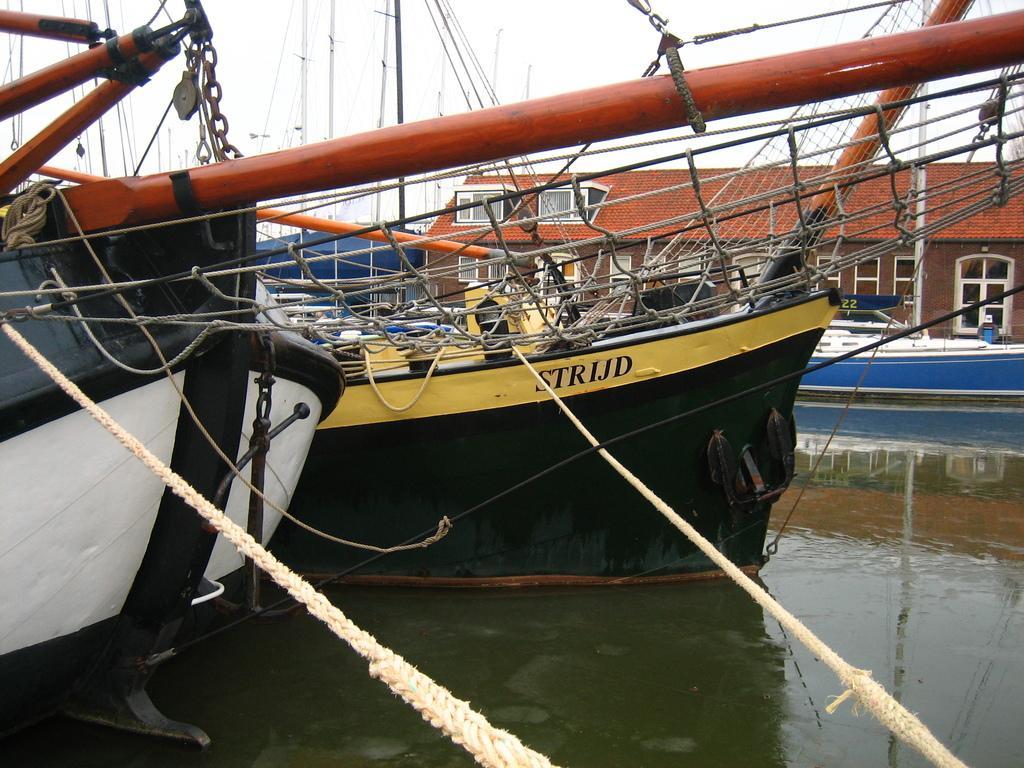Could you give a brief overview of what you see in this image? This image is taken outdoors. At the top of the image there is the sky. At the bottom of the image there is a river with water. In the background there is a house with walls, windows and a roof. In the middle of the image there are a few boats on the river. There are many ropes and chains. There are a few iron bars. 